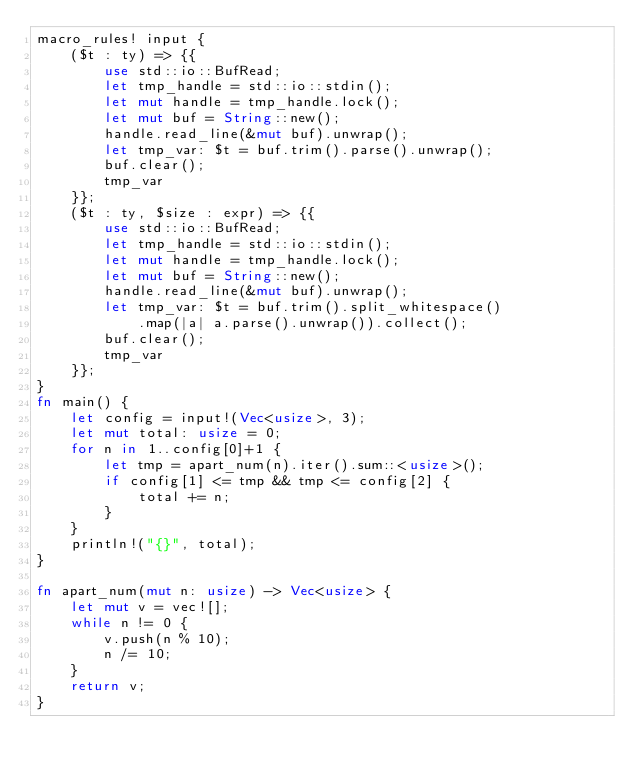<code> <loc_0><loc_0><loc_500><loc_500><_Rust_>macro_rules! input {
    ($t : ty) => {{
        use std::io::BufRead;
        let tmp_handle = std::io::stdin();
        let mut handle = tmp_handle.lock();
        let mut buf = String::new();
        handle.read_line(&mut buf).unwrap();
        let tmp_var: $t = buf.trim().parse().unwrap(); 
        buf.clear();
        tmp_var
    }};
    ($t : ty, $size : expr) => {{
        use std::io::BufRead;
        let tmp_handle = std::io::stdin();
        let mut handle = tmp_handle.lock();
        let mut buf = String::new();
        handle.read_line(&mut buf).unwrap();
        let tmp_var: $t = buf.trim().split_whitespace()
            .map(|a| a.parse().unwrap()).collect();
        buf.clear();
        tmp_var
    }};
}
fn main() {
    let config = input!(Vec<usize>, 3);
    let mut total: usize = 0;
    for n in 1..config[0]+1 {
        let tmp = apart_num(n).iter().sum::<usize>();
        if config[1] <= tmp && tmp <= config[2] {
            total += n;
        }
    }
    println!("{}", total);
}

fn apart_num(mut n: usize) -> Vec<usize> {
    let mut v = vec![];
    while n != 0 {
        v.push(n % 10);
        n /= 10;
    }
    return v;
}
</code> 